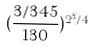Convert formula to latex. <formula><loc_0><loc_0><loc_500><loc_500>( \frac { 3 / 3 4 5 } { 1 3 0 } ) ^ { 2 ^ { 3 } / 4 }</formula> 